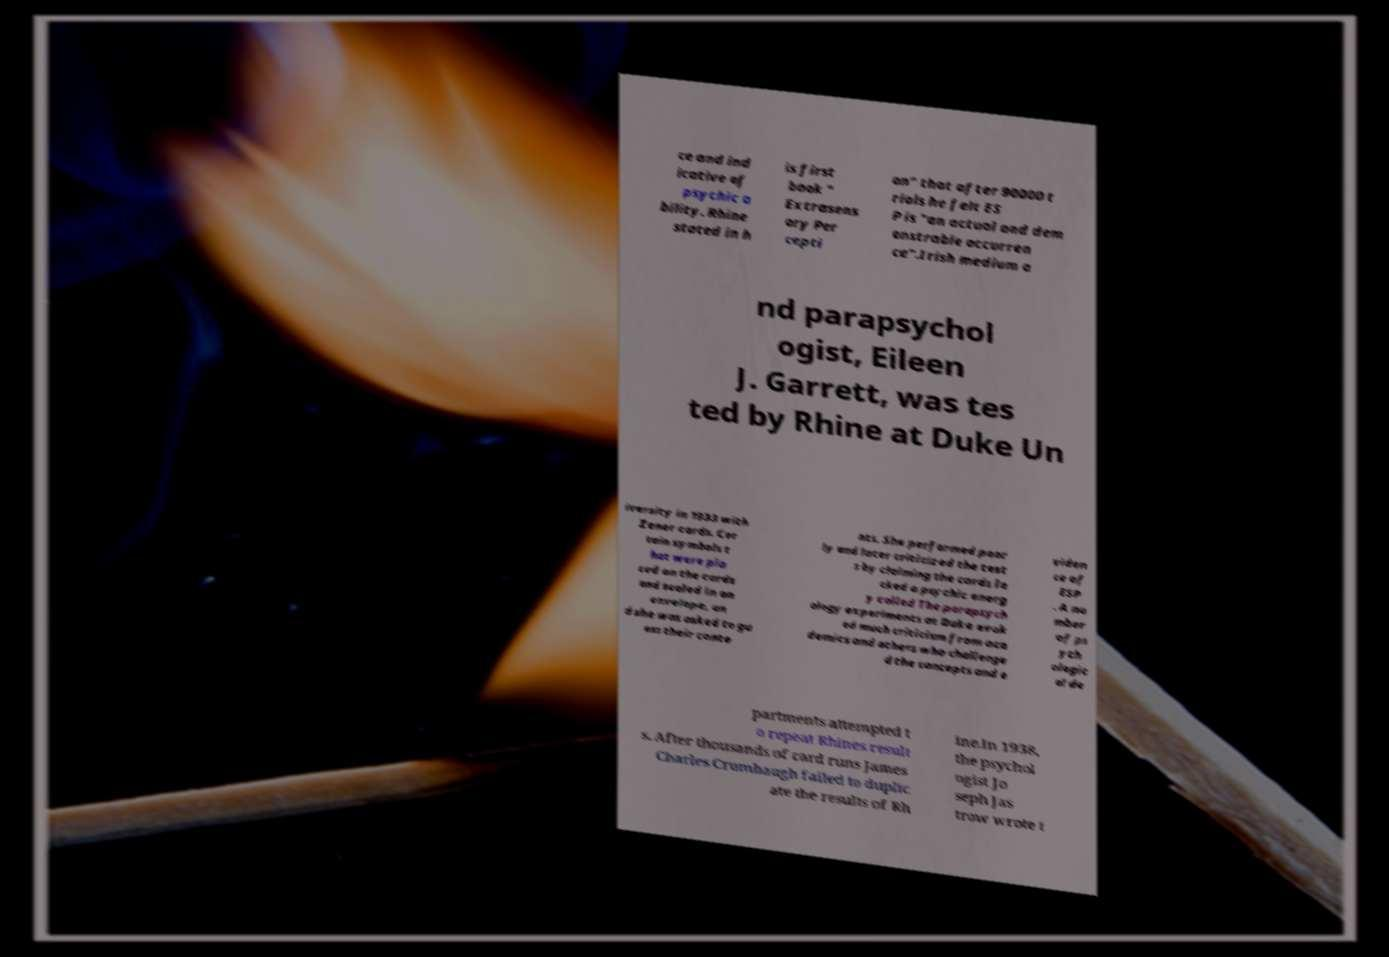Can you accurately transcribe the text from the provided image for me? ce and ind icative of psychic a bility. Rhine stated in h is first book " Extrasens ory Per cepti on" that after 90000 t rials he felt ES P is "an actual and dem onstrable occurren ce".Irish medium a nd parapsychol ogist, Eileen J. Garrett, was tes ted by Rhine at Duke Un iversity in 1933 with Zener cards. Cer tain symbols t hat were pla ced on the cards and sealed in an envelope, an d she was asked to gu ess their conte nts. She performed poor ly and later criticized the test s by claiming the cards la cked a psychic energ y called The parapsych ology experiments at Duke evok ed much criticism from aca demics and others who challenge d the concepts and e viden ce of ESP . A nu mber of ps ych ologic al de partments attempted t o repeat Rhines result s. After thousands of card runs James Charles Crumbaugh failed to duplic ate the results of Rh ine.In 1938, the psychol ogist Jo seph Jas trow wrote t 